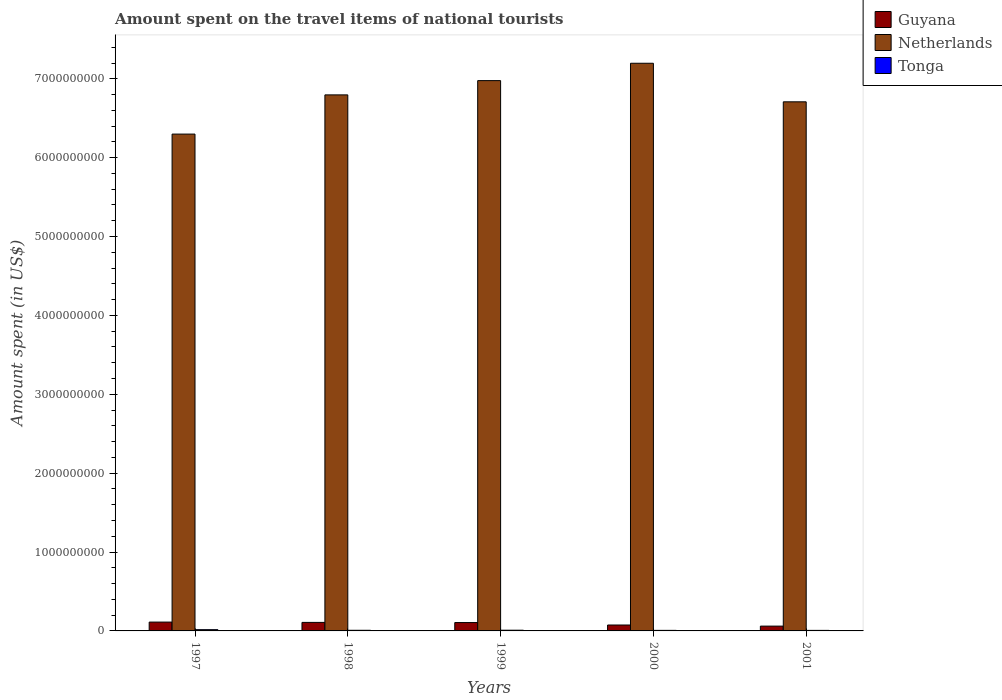How many different coloured bars are there?
Your response must be concise. 3. How many groups of bars are there?
Offer a very short reply. 5. Are the number of bars on each tick of the X-axis equal?
Offer a terse response. Yes. What is the label of the 5th group of bars from the left?
Provide a short and direct response. 2001. In how many cases, is the number of bars for a given year not equal to the number of legend labels?
Offer a very short reply. 0. What is the amount spent on the travel items of national tourists in Guyana in 1997?
Give a very brief answer. 1.12e+08. Across all years, what is the maximum amount spent on the travel items of national tourists in Netherlands?
Ensure brevity in your answer.  7.20e+09. Across all years, what is the minimum amount spent on the travel items of national tourists in Guyana?
Ensure brevity in your answer.  6.10e+07. In which year was the amount spent on the travel items of national tourists in Tonga maximum?
Your answer should be very brief. 1997. What is the total amount spent on the travel items of national tourists in Guyana in the graph?
Offer a terse response. 4.62e+08. What is the difference between the amount spent on the travel items of national tourists in Netherlands in 1997 and that in 1999?
Offer a terse response. -6.78e+08. What is the difference between the amount spent on the travel items of national tourists in Tonga in 1998 and the amount spent on the travel items of national tourists in Guyana in 1997?
Provide a succinct answer. -1.04e+08. What is the average amount spent on the travel items of national tourists in Guyana per year?
Provide a short and direct response. 9.24e+07. In the year 1999, what is the difference between the amount spent on the travel items of national tourists in Guyana and amount spent on the travel items of national tourists in Tonga?
Make the answer very short. 9.70e+07. In how many years, is the amount spent on the travel items of national tourists in Guyana greater than 7200000000 US$?
Provide a short and direct response. 0. What is the ratio of the amount spent on the travel items of national tourists in Tonga in 1998 to that in 2001?
Provide a succinct answer. 1.18. Is the amount spent on the travel items of national tourists in Netherlands in 1998 less than that in 2000?
Provide a short and direct response. Yes. Is the difference between the amount spent on the travel items of national tourists in Guyana in 1997 and 2000 greater than the difference between the amount spent on the travel items of national tourists in Tonga in 1997 and 2000?
Make the answer very short. Yes. What is the difference between the highest and the lowest amount spent on the travel items of national tourists in Tonga?
Make the answer very short. 9.20e+06. In how many years, is the amount spent on the travel items of national tourists in Netherlands greater than the average amount spent on the travel items of national tourists in Netherlands taken over all years?
Ensure brevity in your answer.  3. Is the sum of the amount spent on the travel items of national tourists in Netherlands in 1997 and 1998 greater than the maximum amount spent on the travel items of national tourists in Guyana across all years?
Keep it short and to the point. Yes. What does the 1st bar from the left in 1997 represents?
Offer a very short reply. Guyana. What does the 1st bar from the right in 1999 represents?
Provide a short and direct response. Tonga. How many years are there in the graph?
Keep it short and to the point. 5. Are the values on the major ticks of Y-axis written in scientific E-notation?
Your response must be concise. No. Does the graph contain any zero values?
Your response must be concise. No. Where does the legend appear in the graph?
Your answer should be compact. Top right. How many legend labels are there?
Offer a terse response. 3. What is the title of the graph?
Offer a terse response. Amount spent on the travel items of national tourists. What is the label or title of the Y-axis?
Keep it short and to the point. Amount spent (in US$). What is the Amount spent (in US$) in Guyana in 1997?
Offer a very short reply. 1.12e+08. What is the Amount spent (in US$) of Netherlands in 1997?
Your answer should be compact. 6.30e+09. What is the Amount spent (in US$) in Tonga in 1997?
Ensure brevity in your answer.  1.60e+07. What is the Amount spent (in US$) in Guyana in 1998?
Make the answer very short. 1.08e+08. What is the Amount spent (in US$) of Netherlands in 1998?
Provide a succinct answer. 6.80e+09. What is the Amount spent (in US$) in Tonga in 1998?
Ensure brevity in your answer.  8.00e+06. What is the Amount spent (in US$) in Guyana in 1999?
Make the answer very short. 1.06e+08. What is the Amount spent (in US$) of Netherlands in 1999?
Provide a succinct answer. 6.98e+09. What is the Amount spent (in US$) of Tonga in 1999?
Your answer should be very brief. 9.00e+06. What is the Amount spent (in US$) in Guyana in 2000?
Provide a short and direct response. 7.50e+07. What is the Amount spent (in US$) of Netherlands in 2000?
Your answer should be very brief. 7.20e+09. What is the Amount spent (in US$) of Guyana in 2001?
Ensure brevity in your answer.  6.10e+07. What is the Amount spent (in US$) of Netherlands in 2001?
Provide a succinct answer. 6.71e+09. What is the Amount spent (in US$) of Tonga in 2001?
Provide a succinct answer. 6.80e+06. Across all years, what is the maximum Amount spent (in US$) in Guyana?
Ensure brevity in your answer.  1.12e+08. Across all years, what is the maximum Amount spent (in US$) of Netherlands?
Your response must be concise. 7.20e+09. Across all years, what is the maximum Amount spent (in US$) in Tonga?
Ensure brevity in your answer.  1.60e+07. Across all years, what is the minimum Amount spent (in US$) in Guyana?
Keep it short and to the point. 6.10e+07. Across all years, what is the minimum Amount spent (in US$) in Netherlands?
Provide a succinct answer. 6.30e+09. Across all years, what is the minimum Amount spent (in US$) in Tonga?
Keep it short and to the point. 6.80e+06. What is the total Amount spent (in US$) of Guyana in the graph?
Your answer should be compact. 4.62e+08. What is the total Amount spent (in US$) in Netherlands in the graph?
Your answer should be compact. 3.40e+1. What is the total Amount spent (in US$) in Tonga in the graph?
Provide a short and direct response. 4.68e+07. What is the difference between the Amount spent (in US$) in Netherlands in 1997 and that in 1998?
Keep it short and to the point. -4.97e+08. What is the difference between the Amount spent (in US$) of Guyana in 1997 and that in 1999?
Offer a terse response. 6.00e+06. What is the difference between the Amount spent (in US$) of Netherlands in 1997 and that in 1999?
Ensure brevity in your answer.  -6.78e+08. What is the difference between the Amount spent (in US$) of Tonga in 1997 and that in 1999?
Make the answer very short. 7.00e+06. What is the difference between the Amount spent (in US$) of Guyana in 1997 and that in 2000?
Make the answer very short. 3.70e+07. What is the difference between the Amount spent (in US$) in Netherlands in 1997 and that in 2000?
Your answer should be very brief. -8.98e+08. What is the difference between the Amount spent (in US$) in Tonga in 1997 and that in 2000?
Offer a very short reply. 9.00e+06. What is the difference between the Amount spent (in US$) of Guyana in 1997 and that in 2001?
Offer a terse response. 5.10e+07. What is the difference between the Amount spent (in US$) of Netherlands in 1997 and that in 2001?
Your answer should be very brief. -4.09e+08. What is the difference between the Amount spent (in US$) of Tonga in 1997 and that in 2001?
Offer a very short reply. 9.20e+06. What is the difference between the Amount spent (in US$) in Guyana in 1998 and that in 1999?
Make the answer very short. 2.00e+06. What is the difference between the Amount spent (in US$) in Netherlands in 1998 and that in 1999?
Offer a terse response. -1.81e+08. What is the difference between the Amount spent (in US$) in Guyana in 1998 and that in 2000?
Offer a very short reply. 3.30e+07. What is the difference between the Amount spent (in US$) of Netherlands in 1998 and that in 2000?
Keep it short and to the point. -4.01e+08. What is the difference between the Amount spent (in US$) of Guyana in 1998 and that in 2001?
Make the answer very short. 4.70e+07. What is the difference between the Amount spent (in US$) in Netherlands in 1998 and that in 2001?
Give a very brief answer. 8.80e+07. What is the difference between the Amount spent (in US$) in Tonga in 1998 and that in 2001?
Your answer should be compact. 1.20e+06. What is the difference between the Amount spent (in US$) in Guyana in 1999 and that in 2000?
Keep it short and to the point. 3.10e+07. What is the difference between the Amount spent (in US$) in Netherlands in 1999 and that in 2000?
Offer a terse response. -2.20e+08. What is the difference between the Amount spent (in US$) in Guyana in 1999 and that in 2001?
Ensure brevity in your answer.  4.50e+07. What is the difference between the Amount spent (in US$) in Netherlands in 1999 and that in 2001?
Offer a very short reply. 2.69e+08. What is the difference between the Amount spent (in US$) in Tonga in 1999 and that in 2001?
Your answer should be very brief. 2.20e+06. What is the difference between the Amount spent (in US$) of Guyana in 2000 and that in 2001?
Your response must be concise. 1.40e+07. What is the difference between the Amount spent (in US$) in Netherlands in 2000 and that in 2001?
Give a very brief answer. 4.89e+08. What is the difference between the Amount spent (in US$) in Tonga in 2000 and that in 2001?
Your response must be concise. 2.00e+05. What is the difference between the Amount spent (in US$) of Guyana in 1997 and the Amount spent (in US$) of Netherlands in 1998?
Your response must be concise. -6.68e+09. What is the difference between the Amount spent (in US$) of Guyana in 1997 and the Amount spent (in US$) of Tonga in 1998?
Make the answer very short. 1.04e+08. What is the difference between the Amount spent (in US$) of Netherlands in 1997 and the Amount spent (in US$) of Tonga in 1998?
Your answer should be compact. 6.29e+09. What is the difference between the Amount spent (in US$) in Guyana in 1997 and the Amount spent (in US$) in Netherlands in 1999?
Ensure brevity in your answer.  -6.86e+09. What is the difference between the Amount spent (in US$) in Guyana in 1997 and the Amount spent (in US$) in Tonga in 1999?
Make the answer very short. 1.03e+08. What is the difference between the Amount spent (in US$) in Netherlands in 1997 and the Amount spent (in US$) in Tonga in 1999?
Provide a short and direct response. 6.29e+09. What is the difference between the Amount spent (in US$) in Guyana in 1997 and the Amount spent (in US$) in Netherlands in 2000?
Offer a very short reply. -7.08e+09. What is the difference between the Amount spent (in US$) of Guyana in 1997 and the Amount spent (in US$) of Tonga in 2000?
Offer a terse response. 1.05e+08. What is the difference between the Amount spent (in US$) of Netherlands in 1997 and the Amount spent (in US$) of Tonga in 2000?
Your answer should be very brief. 6.29e+09. What is the difference between the Amount spent (in US$) in Guyana in 1997 and the Amount spent (in US$) in Netherlands in 2001?
Keep it short and to the point. -6.60e+09. What is the difference between the Amount spent (in US$) of Guyana in 1997 and the Amount spent (in US$) of Tonga in 2001?
Your answer should be compact. 1.05e+08. What is the difference between the Amount spent (in US$) in Netherlands in 1997 and the Amount spent (in US$) in Tonga in 2001?
Provide a short and direct response. 6.29e+09. What is the difference between the Amount spent (in US$) of Guyana in 1998 and the Amount spent (in US$) of Netherlands in 1999?
Provide a short and direct response. -6.87e+09. What is the difference between the Amount spent (in US$) in Guyana in 1998 and the Amount spent (in US$) in Tonga in 1999?
Offer a terse response. 9.90e+07. What is the difference between the Amount spent (in US$) in Netherlands in 1998 and the Amount spent (in US$) in Tonga in 1999?
Offer a terse response. 6.79e+09. What is the difference between the Amount spent (in US$) of Guyana in 1998 and the Amount spent (in US$) of Netherlands in 2000?
Your answer should be compact. -7.09e+09. What is the difference between the Amount spent (in US$) in Guyana in 1998 and the Amount spent (in US$) in Tonga in 2000?
Offer a very short reply. 1.01e+08. What is the difference between the Amount spent (in US$) in Netherlands in 1998 and the Amount spent (in US$) in Tonga in 2000?
Your answer should be compact. 6.79e+09. What is the difference between the Amount spent (in US$) of Guyana in 1998 and the Amount spent (in US$) of Netherlands in 2001?
Make the answer very short. -6.60e+09. What is the difference between the Amount spent (in US$) of Guyana in 1998 and the Amount spent (in US$) of Tonga in 2001?
Make the answer very short. 1.01e+08. What is the difference between the Amount spent (in US$) in Netherlands in 1998 and the Amount spent (in US$) in Tonga in 2001?
Make the answer very short. 6.79e+09. What is the difference between the Amount spent (in US$) of Guyana in 1999 and the Amount spent (in US$) of Netherlands in 2000?
Offer a very short reply. -7.09e+09. What is the difference between the Amount spent (in US$) of Guyana in 1999 and the Amount spent (in US$) of Tonga in 2000?
Offer a terse response. 9.90e+07. What is the difference between the Amount spent (in US$) of Netherlands in 1999 and the Amount spent (in US$) of Tonga in 2000?
Offer a very short reply. 6.97e+09. What is the difference between the Amount spent (in US$) of Guyana in 1999 and the Amount spent (in US$) of Netherlands in 2001?
Your response must be concise. -6.60e+09. What is the difference between the Amount spent (in US$) in Guyana in 1999 and the Amount spent (in US$) in Tonga in 2001?
Keep it short and to the point. 9.92e+07. What is the difference between the Amount spent (in US$) of Netherlands in 1999 and the Amount spent (in US$) of Tonga in 2001?
Your answer should be compact. 6.97e+09. What is the difference between the Amount spent (in US$) in Guyana in 2000 and the Amount spent (in US$) in Netherlands in 2001?
Your answer should be very brief. -6.63e+09. What is the difference between the Amount spent (in US$) in Guyana in 2000 and the Amount spent (in US$) in Tonga in 2001?
Ensure brevity in your answer.  6.82e+07. What is the difference between the Amount spent (in US$) of Netherlands in 2000 and the Amount spent (in US$) of Tonga in 2001?
Your answer should be compact. 7.19e+09. What is the average Amount spent (in US$) in Guyana per year?
Offer a terse response. 9.24e+07. What is the average Amount spent (in US$) of Netherlands per year?
Give a very brief answer. 6.80e+09. What is the average Amount spent (in US$) in Tonga per year?
Offer a very short reply. 9.36e+06. In the year 1997, what is the difference between the Amount spent (in US$) in Guyana and Amount spent (in US$) in Netherlands?
Make the answer very short. -6.19e+09. In the year 1997, what is the difference between the Amount spent (in US$) in Guyana and Amount spent (in US$) in Tonga?
Your answer should be compact. 9.60e+07. In the year 1997, what is the difference between the Amount spent (in US$) in Netherlands and Amount spent (in US$) in Tonga?
Provide a succinct answer. 6.28e+09. In the year 1998, what is the difference between the Amount spent (in US$) in Guyana and Amount spent (in US$) in Netherlands?
Keep it short and to the point. -6.69e+09. In the year 1998, what is the difference between the Amount spent (in US$) of Netherlands and Amount spent (in US$) of Tonga?
Provide a short and direct response. 6.79e+09. In the year 1999, what is the difference between the Amount spent (in US$) of Guyana and Amount spent (in US$) of Netherlands?
Make the answer very short. -6.87e+09. In the year 1999, what is the difference between the Amount spent (in US$) in Guyana and Amount spent (in US$) in Tonga?
Offer a terse response. 9.70e+07. In the year 1999, what is the difference between the Amount spent (in US$) in Netherlands and Amount spent (in US$) in Tonga?
Provide a succinct answer. 6.97e+09. In the year 2000, what is the difference between the Amount spent (in US$) of Guyana and Amount spent (in US$) of Netherlands?
Keep it short and to the point. -7.12e+09. In the year 2000, what is the difference between the Amount spent (in US$) of Guyana and Amount spent (in US$) of Tonga?
Your answer should be compact. 6.80e+07. In the year 2000, what is the difference between the Amount spent (in US$) in Netherlands and Amount spent (in US$) in Tonga?
Provide a succinct answer. 7.19e+09. In the year 2001, what is the difference between the Amount spent (in US$) in Guyana and Amount spent (in US$) in Netherlands?
Make the answer very short. -6.65e+09. In the year 2001, what is the difference between the Amount spent (in US$) in Guyana and Amount spent (in US$) in Tonga?
Your answer should be very brief. 5.42e+07. In the year 2001, what is the difference between the Amount spent (in US$) of Netherlands and Amount spent (in US$) of Tonga?
Keep it short and to the point. 6.70e+09. What is the ratio of the Amount spent (in US$) in Guyana in 1997 to that in 1998?
Provide a succinct answer. 1.04. What is the ratio of the Amount spent (in US$) of Netherlands in 1997 to that in 1998?
Provide a succinct answer. 0.93. What is the ratio of the Amount spent (in US$) of Tonga in 1997 to that in 1998?
Your answer should be compact. 2. What is the ratio of the Amount spent (in US$) of Guyana in 1997 to that in 1999?
Give a very brief answer. 1.06. What is the ratio of the Amount spent (in US$) in Netherlands in 1997 to that in 1999?
Provide a short and direct response. 0.9. What is the ratio of the Amount spent (in US$) of Tonga in 1997 to that in 1999?
Give a very brief answer. 1.78. What is the ratio of the Amount spent (in US$) of Guyana in 1997 to that in 2000?
Make the answer very short. 1.49. What is the ratio of the Amount spent (in US$) in Netherlands in 1997 to that in 2000?
Your answer should be very brief. 0.88. What is the ratio of the Amount spent (in US$) in Tonga in 1997 to that in 2000?
Ensure brevity in your answer.  2.29. What is the ratio of the Amount spent (in US$) of Guyana in 1997 to that in 2001?
Your answer should be very brief. 1.84. What is the ratio of the Amount spent (in US$) in Netherlands in 1997 to that in 2001?
Make the answer very short. 0.94. What is the ratio of the Amount spent (in US$) in Tonga in 1997 to that in 2001?
Offer a very short reply. 2.35. What is the ratio of the Amount spent (in US$) of Guyana in 1998 to that in 1999?
Your answer should be compact. 1.02. What is the ratio of the Amount spent (in US$) in Netherlands in 1998 to that in 1999?
Give a very brief answer. 0.97. What is the ratio of the Amount spent (in US$) of Guyana in 1998 to that in 2000?
Your answer should be very brief. 1.44. What is the ratio of the Amount spent (in US$) of Netherlands in 1998 to that in 2000?
Offer a terse response. 0.94. What is the ratio of the Amount spent (in US$) of Guyana in 1998 to that in 2001?
Your answer should be very brief. 1.77. What is the ratio of the Amount spent (in US$) in Netherlands in 1998 to that in 2001?
Keep it short and to the point. 1.01. What is the ratio of the Amount spent (in US$) in Tonga in 1998 to that in 2001?
Your answer should be compact. 1.18. What is the ratio of the Amount spent (in US$) of Guyana in 1999 to that in 2000?
Your answer should be very brief. 1.41. What is the ratio of the Amount spent (in US$) of Netherlands in 1999 to that in 2000?
Your answer should be very brief. 0.97. What is the ratio of the Amount spent (in US$) in Guyana in 1999 to that in 2001?
Keep it short and to the point. 1.74. What is the ratio of the Amount spent (in US$) in Netherlands in 1999 to that in 2001?
Give a very brief answer. 1.04. What is the ratio of the Amount spent (in US$) in Tonga in 1999 to that in 2001?
Give a very brief answer. 1.32. What is the ratio of the Amount spent (in US$) of Guyana in 2000 to that in 2001?
Ensure brevity in your answer.  1.23. What is the ratio of the Amount spent (in US$) in Netherlands in 2000 to that in 2001?
Offer a terse response. 1.07. What is the ratio of the Amount spent (in US$) of Tonga in 2000 to that in 2001?
Ensure brevity in your answer.  1.03. What is the difference between the highest and the second highest Amount spent (in US$) of Guyana?
Ensure brevity in your answer.  4.00e+06. What is the difference between the highest and the second highest Amount spent (in US$) of Netherlands?
Offer a terse response. 2.20e+08. What is the difference between the highest and the second highest Amount spent (in US$) of Tonga?
Offer a terse response. 7.00e+06. What is the difference between the highest and the lowest Amount spent (in US$) in Guyana?
Your answer should be compact. 5.10e+07. What is the difference between the highest and the lowest Amount spent (in US$) of Netherlands?
Offer a terse response. 8.98e+08. What is the difference between the highest and the lowest Amount spent (in US$) of Tonga?
Offer a very short reply. 9.20e+06. 